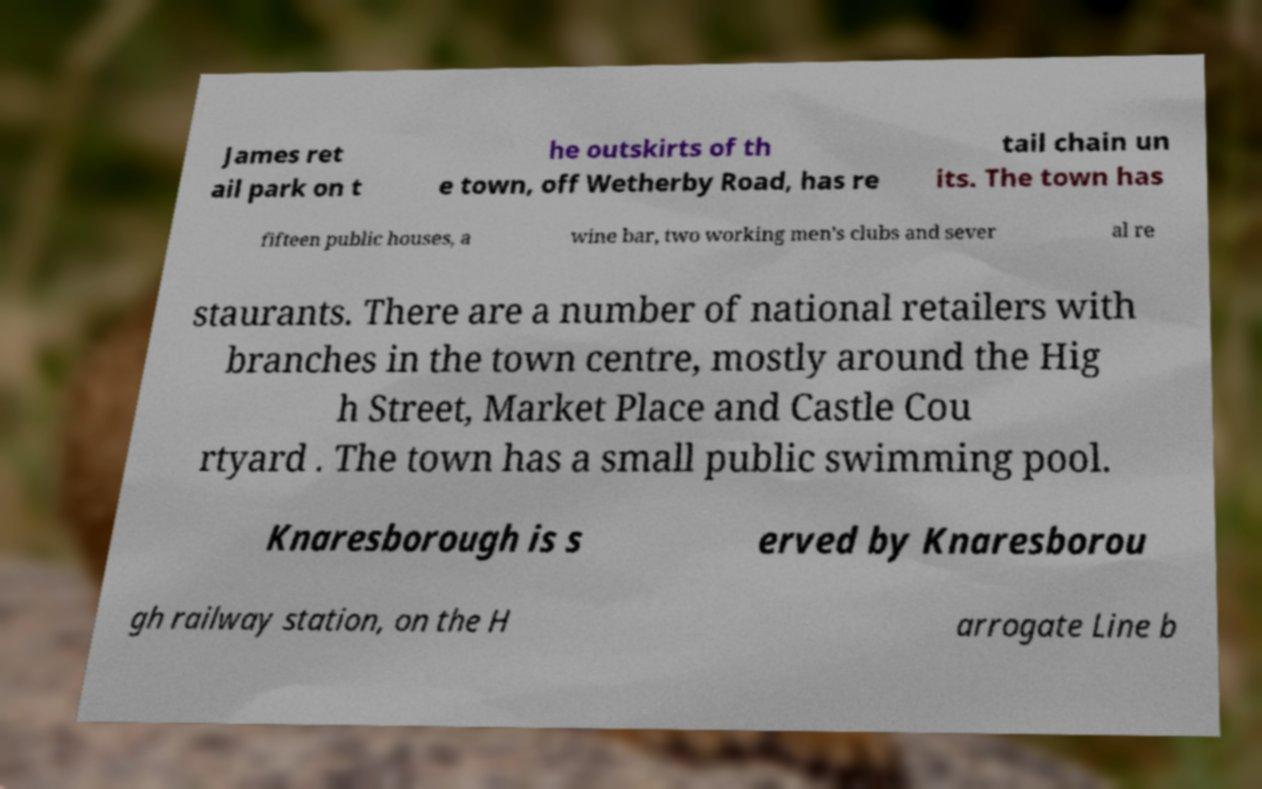Can you read and provide the text displayed in the image?This photo seems to have some interesting text. Can you extract and type it out for me? James ret ail park on t he outskirts of th e town, off Wetherby Road, has re tail chain un its. The town has fifteen public houses, a wine bar, two working men's clubs and sever al re staurants. There are a number of national retailers with branches in the town centre, mostly around the Hig h Street, Market Place and Castle Cou rtyard . The town has a small public swimming pool. Knaresborough is s erved by Knaresborou gh railway station, on the H arrogate Line b 